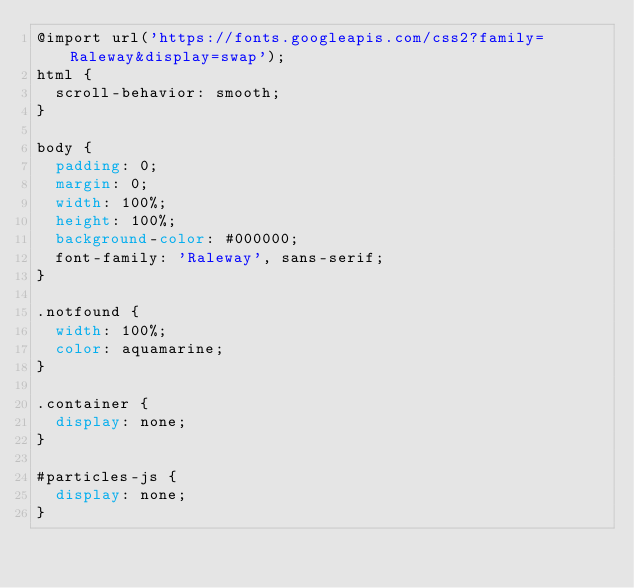Convert code to text. <code><loc_0><loc_0><loc_500><loc_500><_CSS_>@import url('https://fonts.googleapis.com/css2?family=Raleway&display=swap');
html {
  scroll-behavior: smooth;
}

body {
  padding: 0;
  margin: 0;
  width: 100%;
  height: 100%;
  background-color: #000000;
  font-family: 'Raleway', sans-serif;
}

.notfound {
  width: 100%;
  color: aquamarine;
}

.container {
  display: none;
}

#particles-js {
  display: none;
}
</code> 